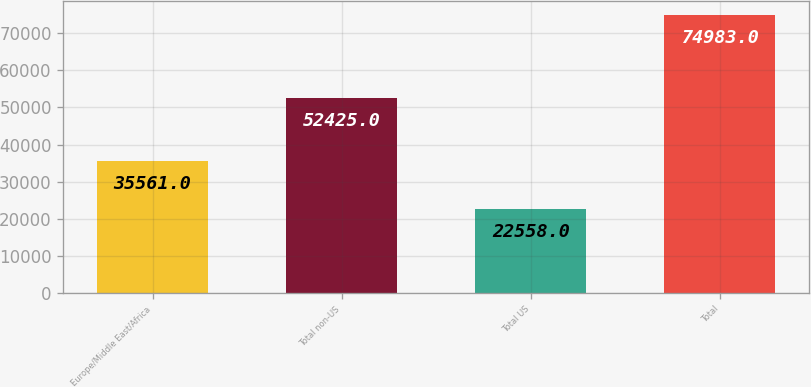Convert chart to OTSL. <chart><loc_0><loc_0><loc_500><loc_500><bar_chart><fcel>Europe/Middle East/Africa<fcel>Total non-US<fcel>Total US<fcel>Total<nl><fcel>35561<fcel>52425<fcel>22558<fcel>74983<nl></chart> 